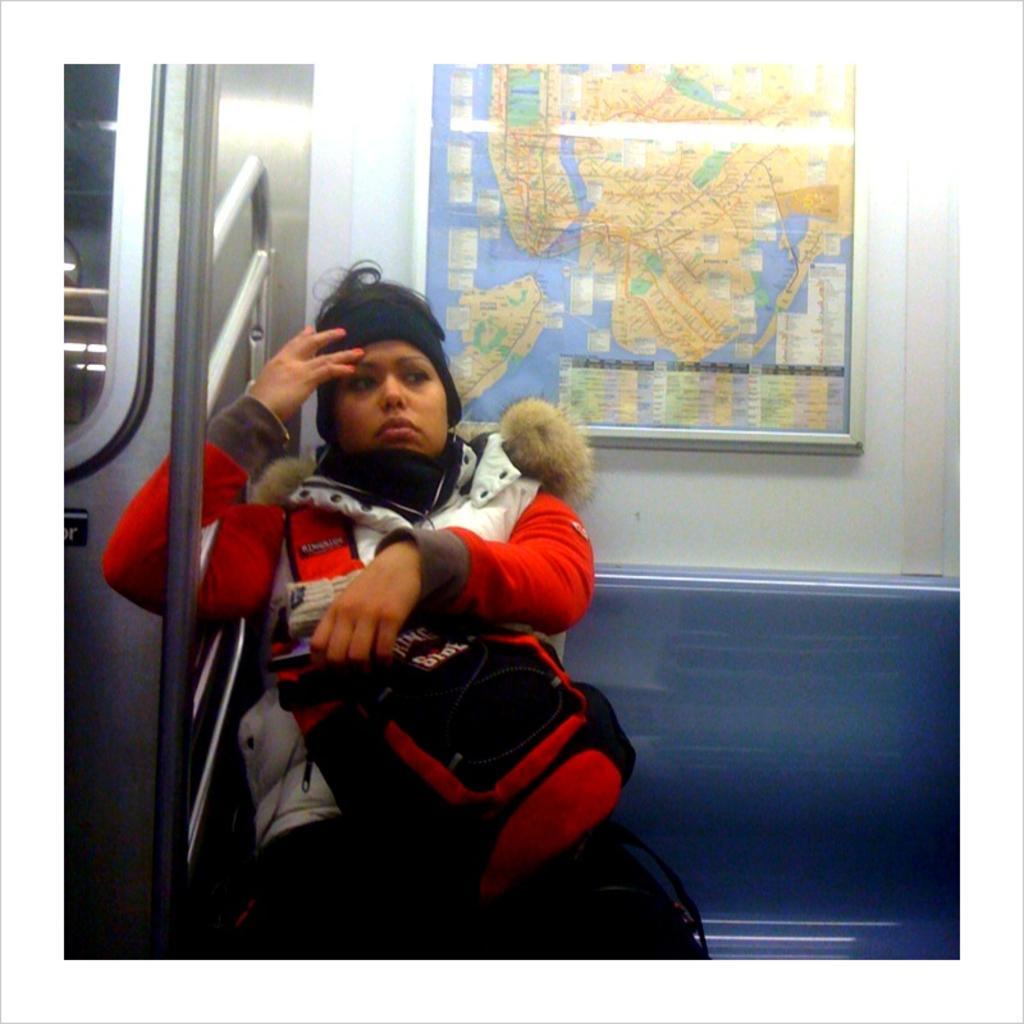In one or two sentences, can you explain what this image depicts? In this image I can see the person holding the bag and wearing the white and red color jacket. I can see the person sitting inside the vehicle. In the background I can see the board. 